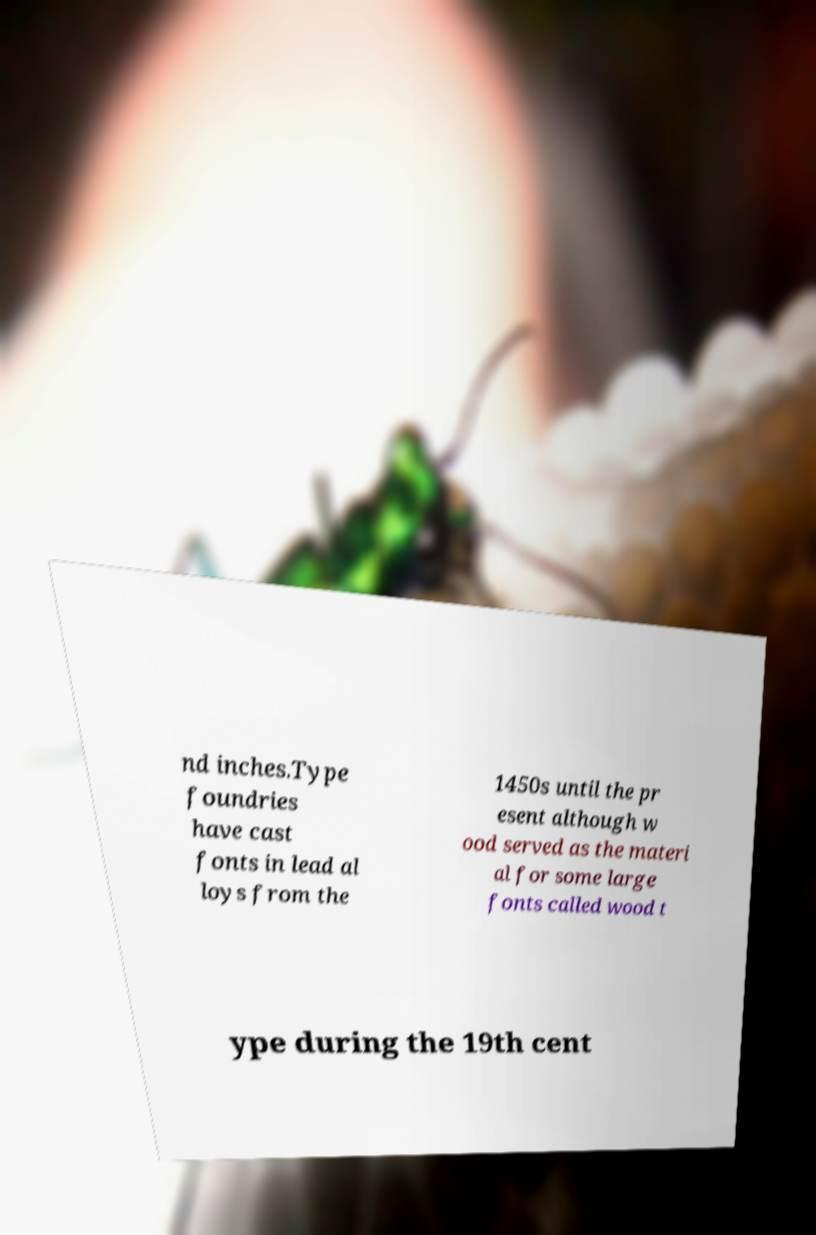There's text embedded in this image that I need extracted. Can you transcribe it verbatim? nd inches.Type foundries have cast fonts in lead al loys from the 1450s until the pr esent although w ood served as the materi al for some large fonts called wood t ype during the 19th cent 